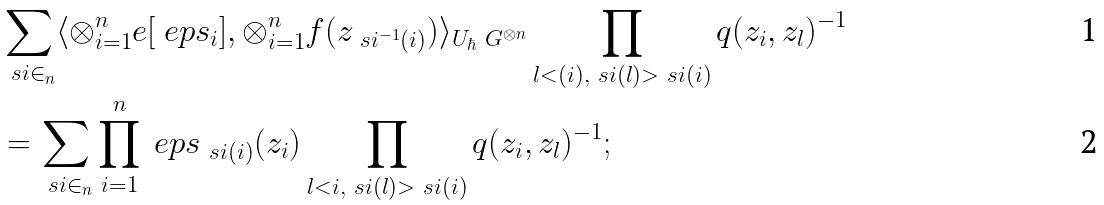Convert formula to latex. <formula><loc_0><loc_0><loc_500><loc_500>& \sum _ { \ s i \in _ { n } } \langle \otimes _ { i = 1 } ^ { n } e [ \ e p s _ { i } ] , \otimes _ { i = 1 } ^ { n } f ( z _ { \ s i ^ { - 1 } ( i ) } ) \rangle _ { U _ { \hbar } \ G ^ { \otimes n } } \prod _ { l < ( i ) , \ s i ( l ) > \ s i ( i ) } q ( z _ { i } , z _ { l } ) ^ { - 1 } \\ & = \sum _ { \ s i \in _ { n } } \prod _ { i = 1 } ^ { n } \ e p s _ { \ s i ( i ) } ( z _ { i } ) \prod _ { l < i , \ s i ( l ) > \ s i ( i ) } q ( z _ { i } , z _ { l } ) ^ { - 1 } ;</formula> 